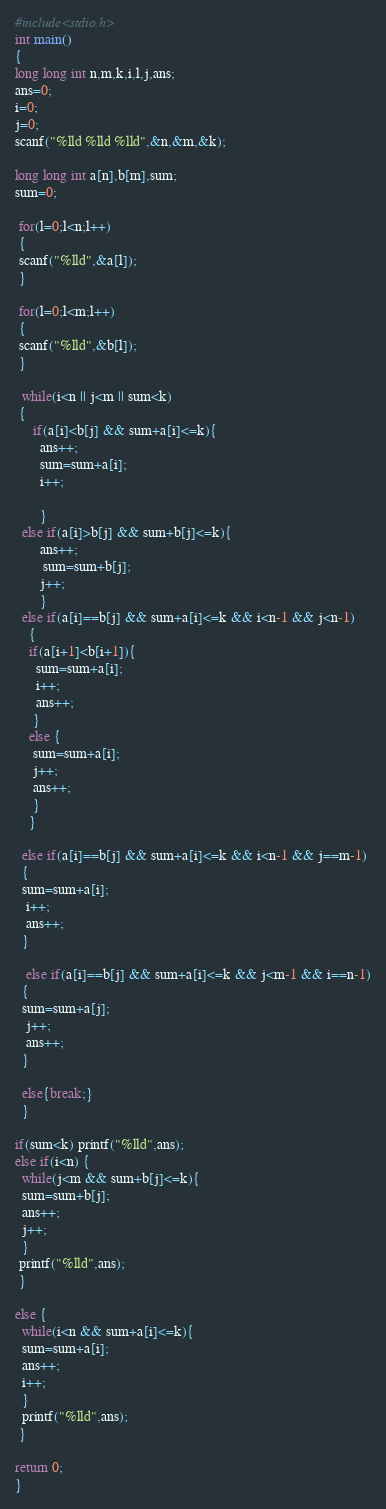<code> <loc_0><loc_0><loc_500><loc_500><_C_>#include<stdio.h>
int main()
{
long long int n,m,k,i,l,j,ans;
ans=0;
i=0;
j=0;
scanf("%lld %lld %lld",&n,&m,&k); 

long long int a[n],b[m],sum;
sum=0;
 
 for(l=0;l<n;l++)
 {
 scanf("%lld",&a[l]);
 }

 for(l=0;l<m;l++)
 {
 scanf("%lld",&b[l]);
 }
  
  while(i<n || j<m || sum<k)
 { 
     if(a[i]<b[j] && sum+a[i]<=k){
       ans++;
       sum=sum+a[i];
       i++;
       
       }
  else if(a[i]>b[j] && sum+b[j]<=k){
       ans++;
        sum=sum+b[j];
       j++;
       }
  else if(a[i]==b[j] && sum+a[i]<=k && i<n-1 && j<n-1)
    {
    if(a[i+1]<b[i+1]){
      sum=sum+a[i];
      i++;
      ans++;
     }
    else {
     sum=sum+a[i];
     j++;
     ans++;
     }
    }
  
  else if(a[i]==b[j] && sum+a[i]<=k && i<n-1 && j==m-1)
  {
  sum=sum+a[i];
   i++;
   ans++;
  }
    
   else if(a[i]==b[j] && sum+a[i]<=k && j<m-1 && i==n-1)
  {
  sum=sum+a[j];
   j++;
   ans++;
  } 
  
  else{break;}
  }
  
if(sum<k) printf("%lld",ans);
else if(i<n) {
  while(j<m && sum+b[j]<=k){
  sum=sum+b[j];
  ans++;
  j++;
  }
 printf("%lld",ans);
 }

else {
  while(i<n && sum+a[i]<=k){
  sum=sum+a[i];
  ans++;
  i++;
  }
  printf("%lld",ans);
 }

return 0;
}</code> 